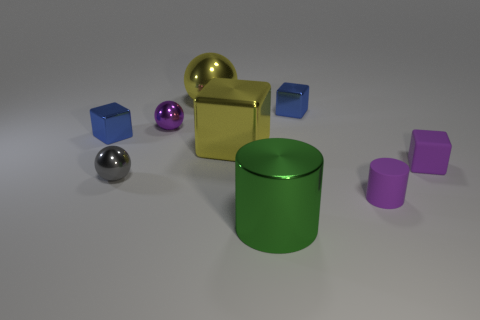Subtract all small cubes. How many cubes are left? 1 Subtract all yellow balls. How many balls are left? 2 Add 2 big shiny cylinders. How many big shiny cylinders exist? 3 Add 1 yellow metal balls. How many objects exist? 10 Subtract 0 cyan cubes. How many objects are left? 9 Subtract all cylinders. How many objects are left? 7 Subtract all green blocks. Subtract all purple cylinders. How many blocks are left? 4 Subtract all yellow blocks. How many red cylinders are left? 0 Subtract all small purple matte cylinders. Subtract all cylinders. How many objects are left? 6 Add 5 tiny gray shiny objects. How many tiny gray shiny objects are left? 6 